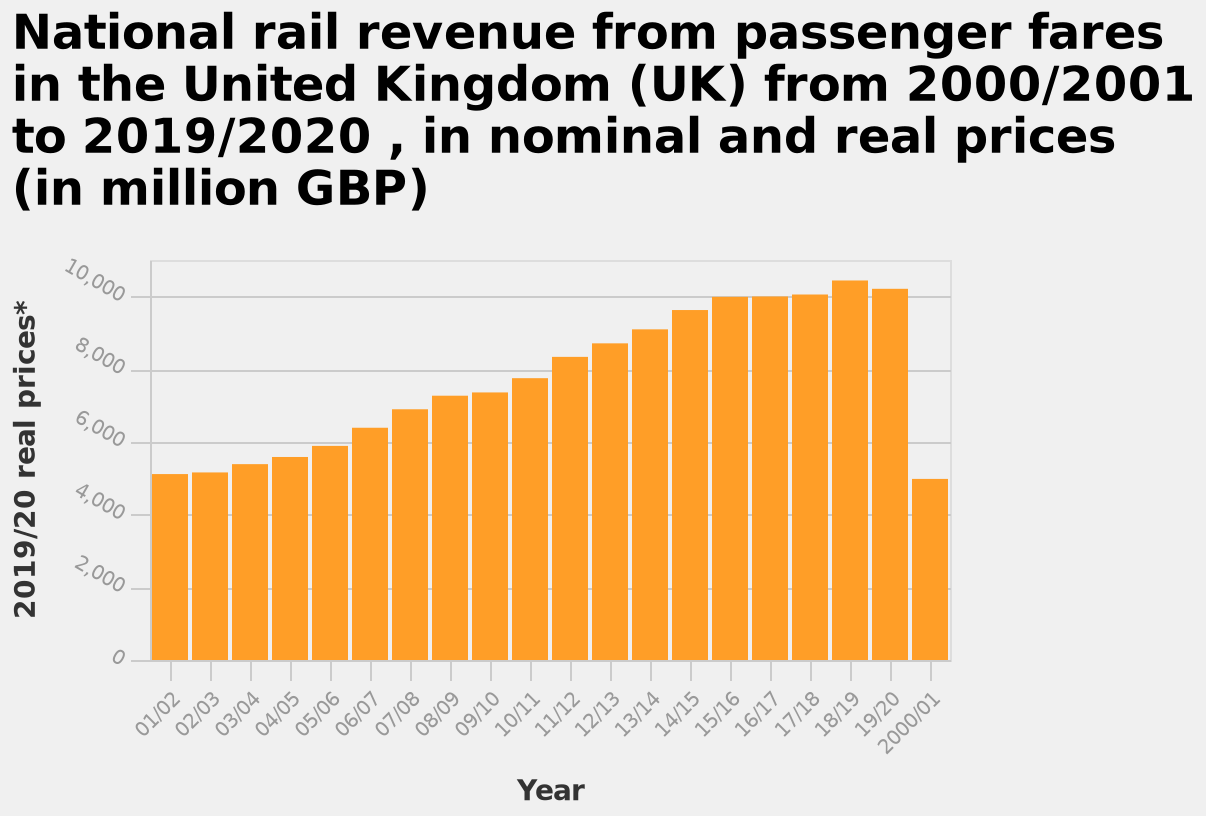<image>
What is the scale on the x-axis? The scale on the x-axis is defined as a categorical scale from 01/02 to 2000/01 representing the years. Was there a decrease in national rail revenue in 18/19 compared to the previous year? No, there was an increase in national rail revenue from the previous year to 18/19. Is the scale on the x-axis defined as a numerical scale from 01/02 to 2000/01 representing the years? No.The scale on the x-axis is defined as a categorical scale from 01/02 to 2000/01 representing the years. 